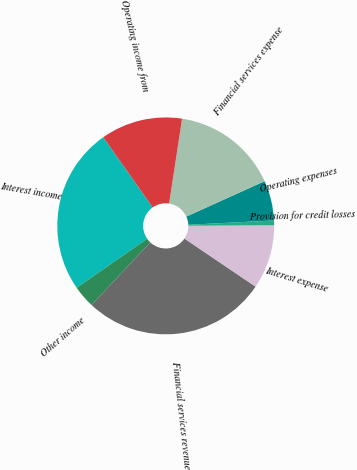<chart> <loc_0><loc_0><loc_500><loc_500><pie_chart><fcel>Interest income<fcel>Other income<fcel>Financial services revenue<fcel>Interest expense<fcel>Provision for credit losses<fcel>Operating expenses<fcel>Financial services expense<fcel>Operating income from<nl><fcel>24.9%<fcel>3.34%<fcel>27.53%<fcel>9.55%<fcel>0.71%<fcel>5.97%<fcel>15.83%<fcel>12.18%<nl></chart> 